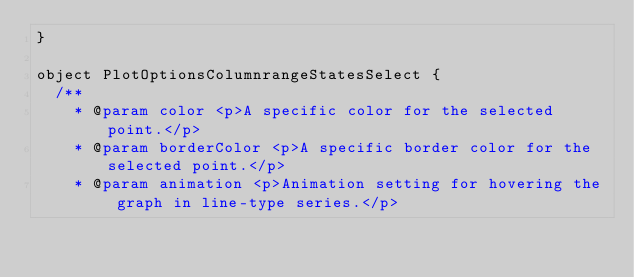Convert code to text. <code><loc_0><loc_0><loc_500><loc_500><_Scala_>}

object PlotOptionsColumnrangeStatesSelect {
  /**
    * @param color <p>A specific color for the selected point.</p>
    * @param borderColor <p>A specific border color for the selected point.</p>
    * @param animation <p>Animation setting for hovering the graph in line-type series.</p></code> 